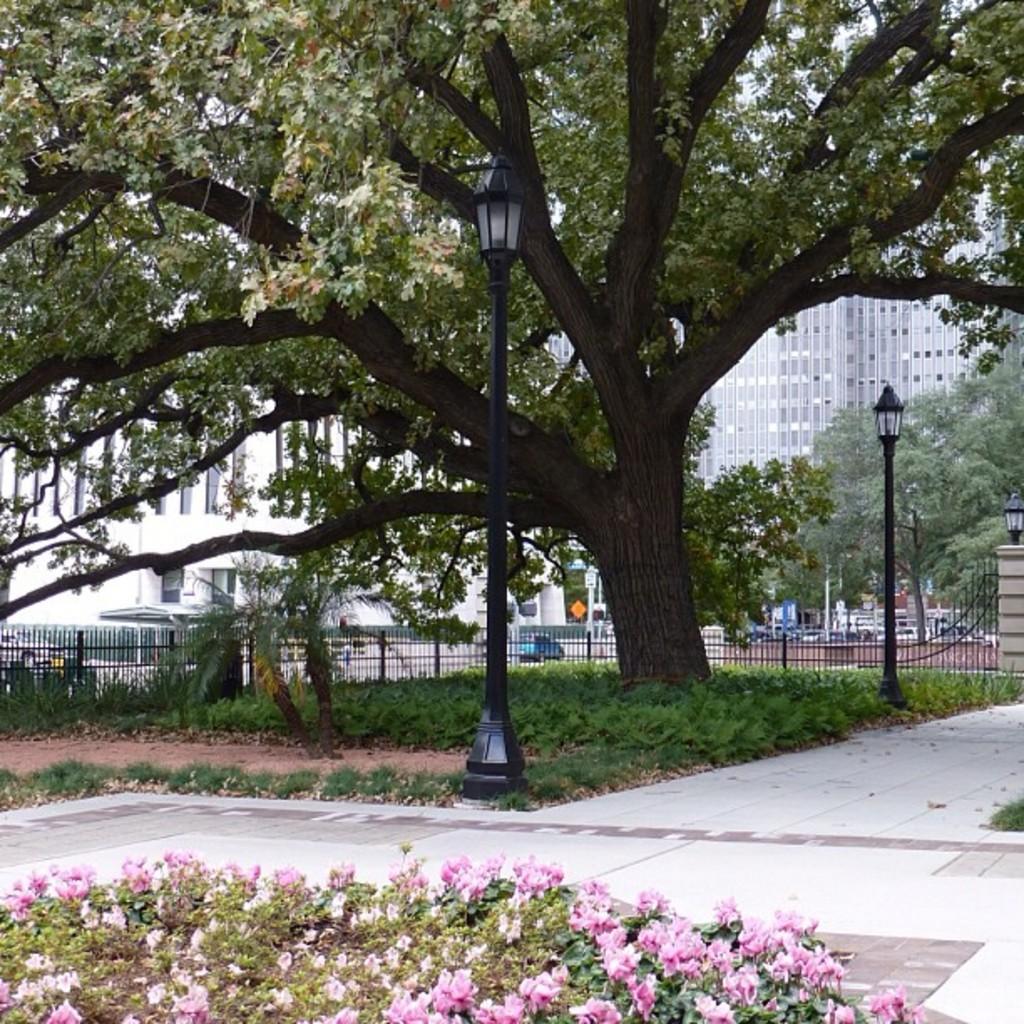In one or two sentences, can you explain what this image depicts? This picture might be taken from outside of the city. In this image, on the left side to middle, we can see a plant with some flowers. In the middle of the image, we can also see a street light, trees. On the right side, we can also see another street light, wall. In the background, we can see some metal grills, window, buildings, trees. At the bottom, we can see some plants and a floor. 